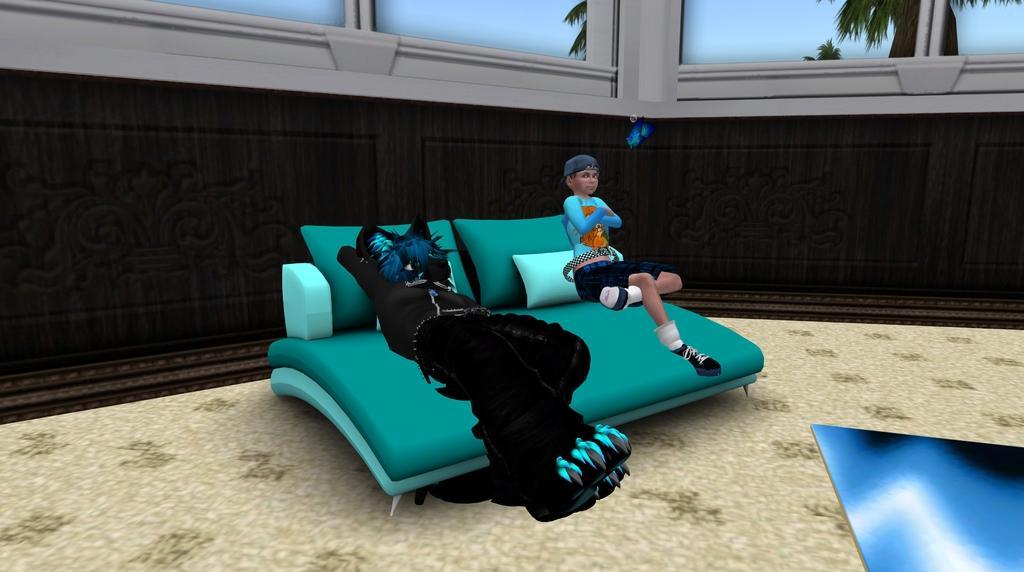Can you describe this image briefly? This is an animated image, in this image there is a sofa on a floor and a person and a cat sitting on a sofa, in the background there is a wall and glass doors. 